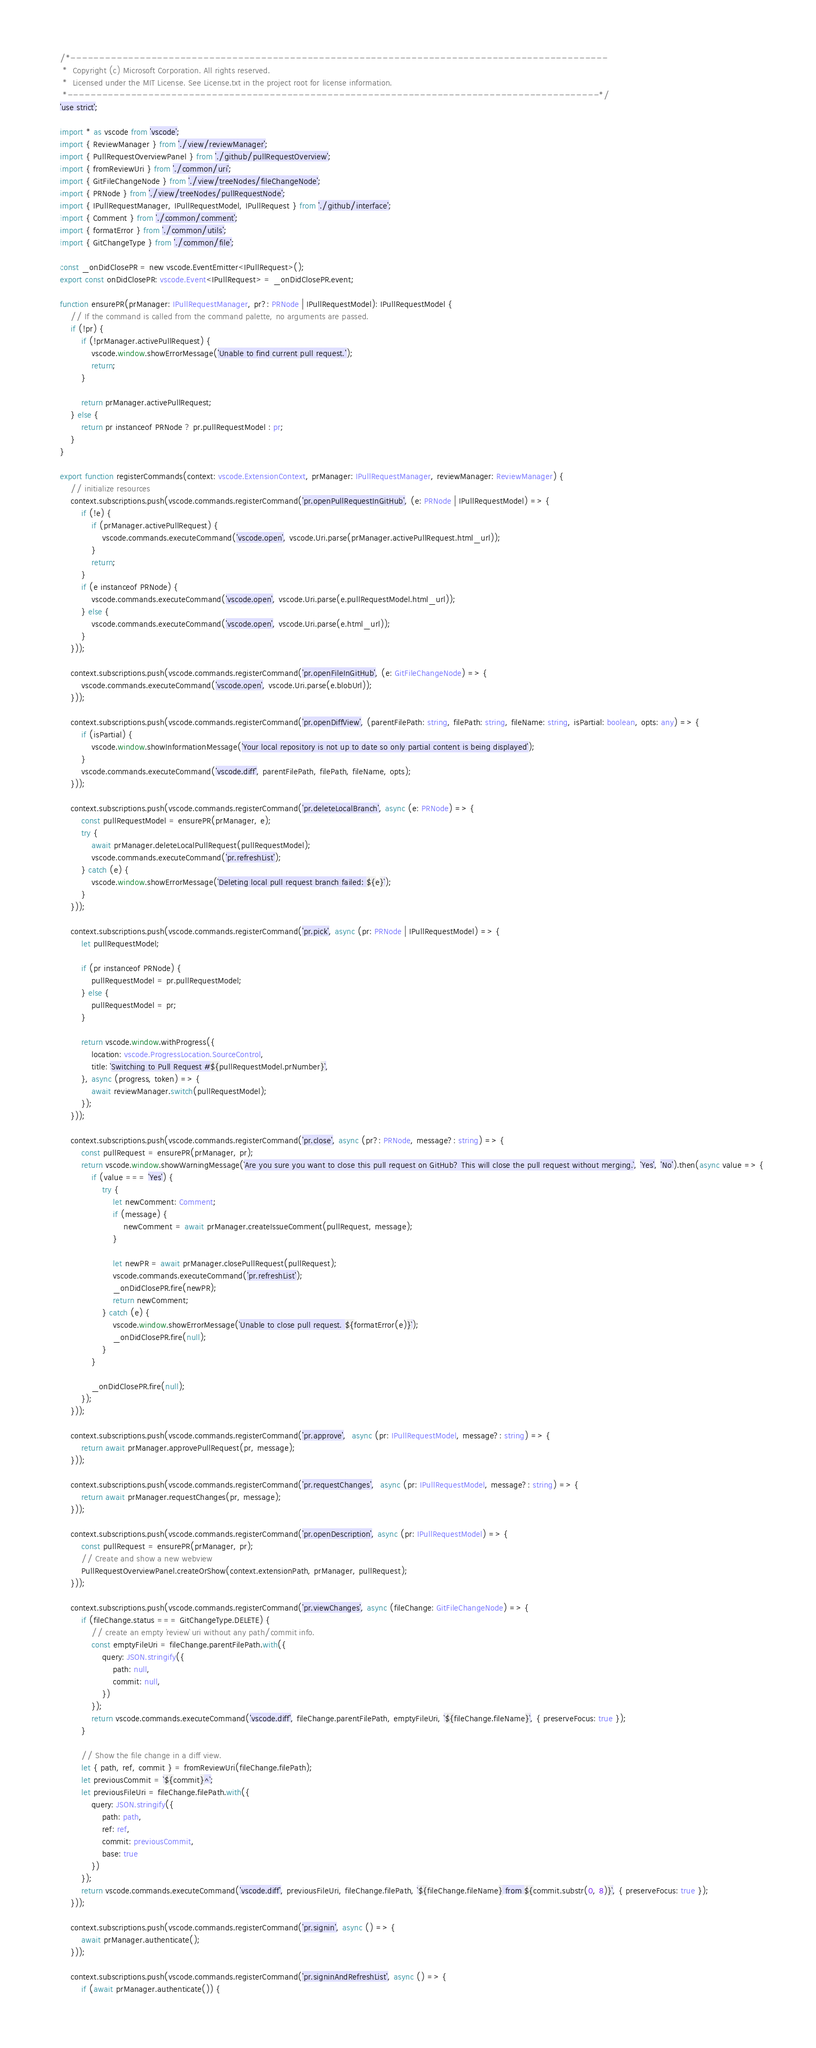<code> <loc_0><loc_0><loc_500><loc_500><_TypeScript_>/*---------------------------------------------------------------------------------------------
 *  Copyright (c) Microsoft Corporation. All rights reserved.
 *  Licensed under the MIT License. See License.txt in the project root for license information.
 *--------------------------------------------------------------------------------------------*/
'use strict';

import * as vscode from 'vscode';
import { ReviewManager } from './view/reviewManager';
import { PullRequestOverviewPanel } from './github/pullRequestOverview';
import { fromReviewUri } from './common/uri';
import { GitFileChangeNode } from './view/treeNodes/fileChangeNode';
import { PRNode } from './view/treeNodes/pullRequestNode';
import { IPullRequestManager, IPullRequestModel, IPullRequest } from './github/interface';
import { Comment } from './common/comment';
import { formatError } from './common/utils';
import { GitChangeType } from './common/file';

const _onDidClosePR = new vscode.EventEmitter<IPullRequest>();
export const onDidClosePR: vscode.Event<IPullRequest> = _onDidClosePR.event;

function ensurePR(prManager: IPullRequestManager, pr?: PRNode | IPullRequestModel): IPullRequestModel {
	// If the command is called from the command palette, no arguments are passed.
	if (!pr) {
		if (!prManager.activePullRequest) {
			vscode.window.showErrorMessage('Unable to find current pull request.');
			return;
		}

		return prManager.activePullRequest;
	} else {
		return pr instanceof PRNode ? pr.pullRequestModel : pr;
	}
}

export function registerCommands(context: vscode.ExtensionContext, prManager: IPullRequestManager, reviewManager: ReviewManager) {
	// initialize resources
	context.subscriptions.push(vscode.commands.registerCommand('pr.openPullRequestInGitHub', (e: PRNode | IPullRequestModel) => {
		if (!e) {
			if (prManager.activePullRequest) {
				vscode.commands.executeCommand('vscode.open', vscode.Uri.parse(prManager.activePullRequest.html_url));
			}
			return;
		}
		if (e instanceof PRNode) {
			vscode.commands.executeCommand('vscode.open', vscode.Uri.parse(e.pullRequestModel.html_url));
		} else {
			vscode.commands.executeCommand('vscode.open', vscode.Uri.parse(e.html_url));
		}
	}));

	context.subscriptions.push(vscode.commands.registerCommand('pr.openFileInGitHub', (e: GitFileChangeNode) => {
		vscode.commands.executeCommand('vscode.open', vscode.Uri.parse(e.blobUrl));
	}));

	context.subscriptions.push(vscode.commands.registerCommand('pr.openDiffView', (parentFilePath: string, filePath: string, fileName: string, isPartial: boolean, opts: any) => {
		if (isPartial) {
			vscode.window.showInformationMessage('Your local repository is not up to date so only partial content is being displayed');
		}
		vscode.commands.executeCommand('vscode.diff', parentFilePath, filePath, fileName, opts);
	}));

	context.subscriptions.push(vscode.commands.registerCommand('pr.deleteLocalBranch', async (e: PRNode) => {
		const pullRequestModel = ensurePR(prManager, e);
		try {
			await prManager.deleteLocalPullRequest(pullRequestModel);
			vscode.commands.executeCommand('pr.refreshList');
		} catch (e) {
			vscode.window.showErrorMessage(`Deleting local pull request branch failed: ${e}`);
		}
	}));

	context.subscriptions.push(vscode.commands.registerCommand('pr.pick', async (pr: PRNode | IPullRequestModel) => {
		let pullRequestModel;

		if (pr instanceof PRNode) {
			pullRequestModel = pr.pullRequestModel;
		} else {
			pullRequestModel = pr;
		}

		return vscode.window.withProgress({
			location: vscode.ProgressLocation.SourceControl,
			title: `Switching to Pull Request #${pullRequestModel.prNumber}`,
		}, async (progress, token) => {
			await reviewManager.switch(pullRequestModel);
		});
	}));

	context.subscriptions.push(vscode.commands.registerCommand('pr.close', async (pr?: PRNode, message?: string) => {
		const pullRequest = ensurePR(prManager, pr);
		return vscode.window.showWarningMessage(`Are you sure you want to close this pull request on GitHub? This will close the pull request without merging.`, 'Yes', 'No').then(async value => {
			if (value === 'Yes') {
				try {
					let newComment: Comment;
					if (message) {
						newComment = await prManager.createIssueComment(pullRequest, message);
					}

					let newPR = await prManager.closePullRequest(pullRequest);
					vscode.commands.executeCommand('pr.refreshList');
					_onDidClosePR.fire(newPR);
					return newComment;
				} catch (e) {
					vscode.window.showErrorMessage(`Unable to close pull request. ${formatError(e)}`);
					_onDidClosePR.fire(null);
				}
			}

			_onDidClosePR.fire(null);
		});
	}));

	context.subscriptions.push(vscode.commands.registerCommand('pr.approve',  async (pr: IPullRequestModel, message?: string) => {
		return await prManager.approvePullRequest(pr, message);
	}));

	context.subscriptions.push(vscode.commands.registerCommand('pr.requestChanges',  async (pr: IPullRequestModel, message?: string) => {
		return await prManager.requestChanges(pr, message);
	}));

	context.subscriptions.push(vscode.commands.registerCommand('pr.openDescription', async (pr: IPullRequestModel) => {
		const pullRequest = ensurePR(prManager, pr);
		// Create and show a new webview
		PullRequestOverviewPanel.createOrShow(context.extensionPath, prManager, pullRequest);
	}));

	context.subscriptions.push(vscode.commands.registerCommand('pr.viewChanges', async (fileChange: GitFileChangeNode) => {
		if (fileChange.status === GitChangeType.DELETE) {
			// create an empty `review` uri without any path/commit info.
			const emptyFileUri = fileChange.parentFilePath.with({
				query: JSON.stringify({
					path: null,
					commit: null,
				})
			});
			return vscode.commands.executeCommand('vscode.diff', fileChange.parentFilePath, emptyFileUri, `${fileChange.fileName}`, { preserveFocus: true });
		}

		// Show the file change in a diff view.
		let { path, ref, commit } = fromReviewUri(fileChange.filePath);
		let previousCommit = `${commit}^`;
		let previousFileUri = fileChange.filePath.with({
			query: JSON.stringify({
				path: path,
				ref: ref,
				commit: previousCommit,
				base: true
			})
		});
		return vscode.commands.executeCommand('vscode.diff', previousFileUri, fileChange.filePath, `${fileChange.fileName} from ${commit.substr(0, 8)}`, { preserveFocus: true });
	}));

	context.subscriptions.push(vscode.commands.registerCommand('pr.signin', async () => {
		await prManager.authenticate();
	}));

	context.subscriptions.push(vscode.commands.registerCommand('pr.signinAndRefreshList', async () => {
		if (await prManager.authenticate()) {</code> 